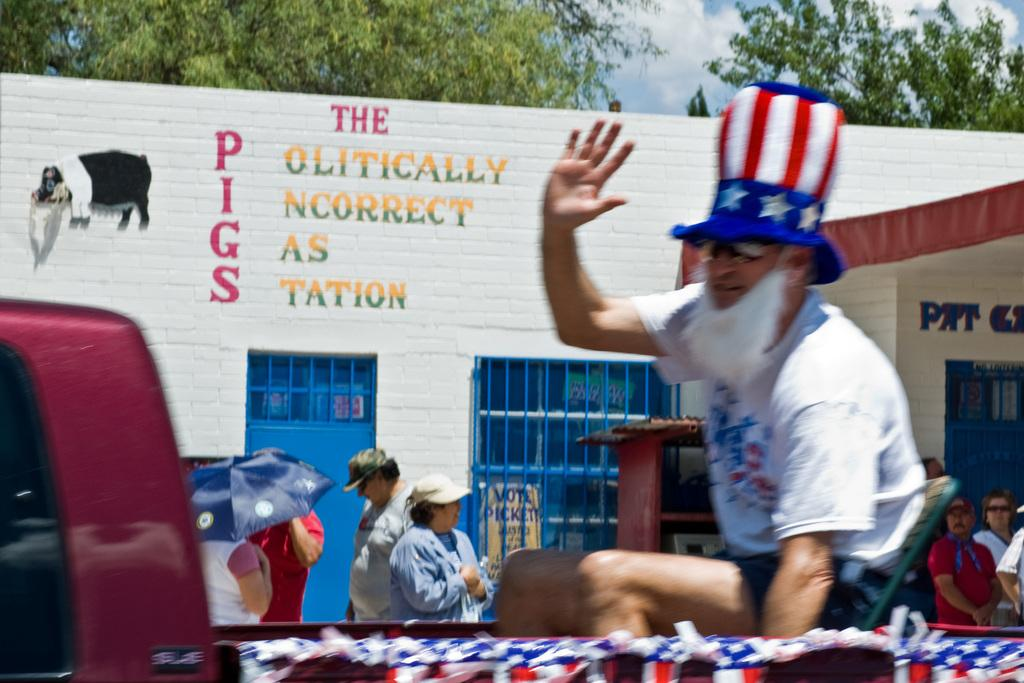Provide a one-sentence caption for the provided image. A man dressed in a patriotic hat waves outside of the Politically Incorrect Gas Station. 